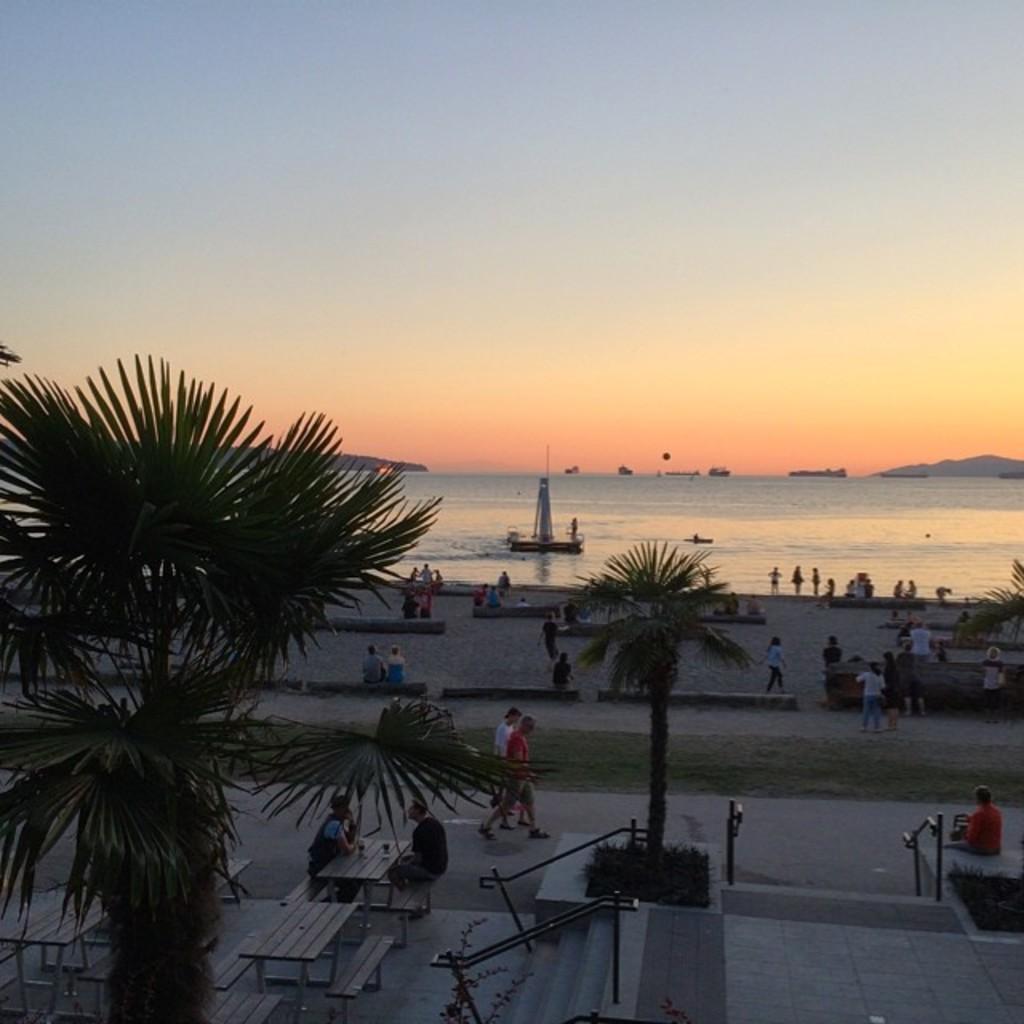Describe this image in one or two sentences. In this picture we can see two persons were sitting on the bench near to the table. On the table there are two wine glasses. Beside them we can see the stairs and grass. On the left we can see the tree. In the background we can see many boats and ships on the water. On the right background there is a mountain. At the top there is a sky. In the bottom right corner we can see a man who is sitting near to the fencing. 